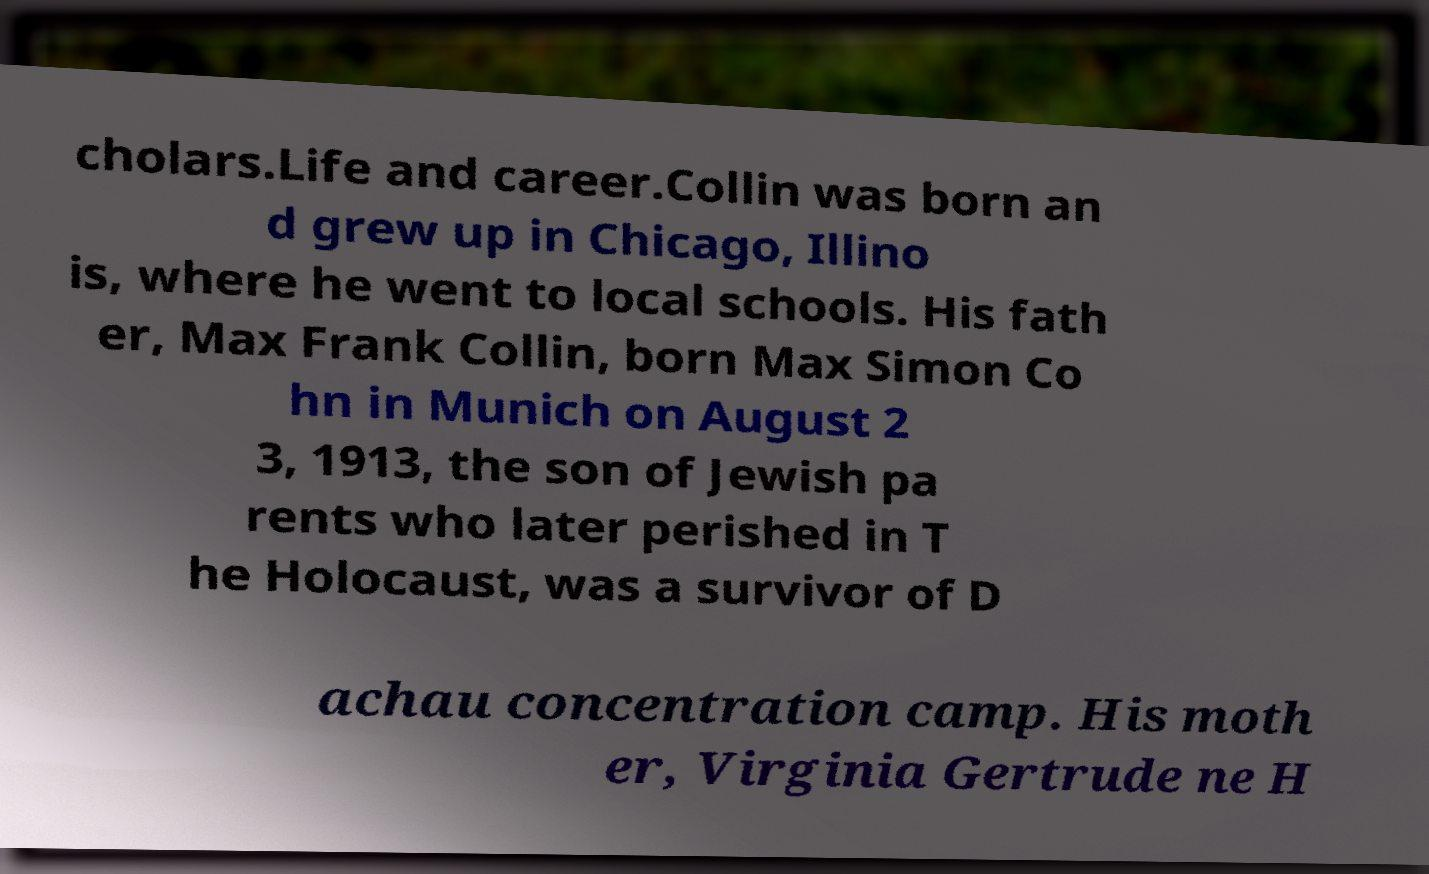I need the written content from this picture converted into text. Can you do that? cholars.Life and career.Collin was born an d grew up in Chicago, Illino is, where he went to local schools. His fath er, Max Frank Collin, born Max Simon Co hn in Munich on August 2 3, 1913, the son of Jewish pa rents who later perished in T he Holocaust, was a survivor of D achau concentration camp. His moth er, Virginia Gertrude ne H 